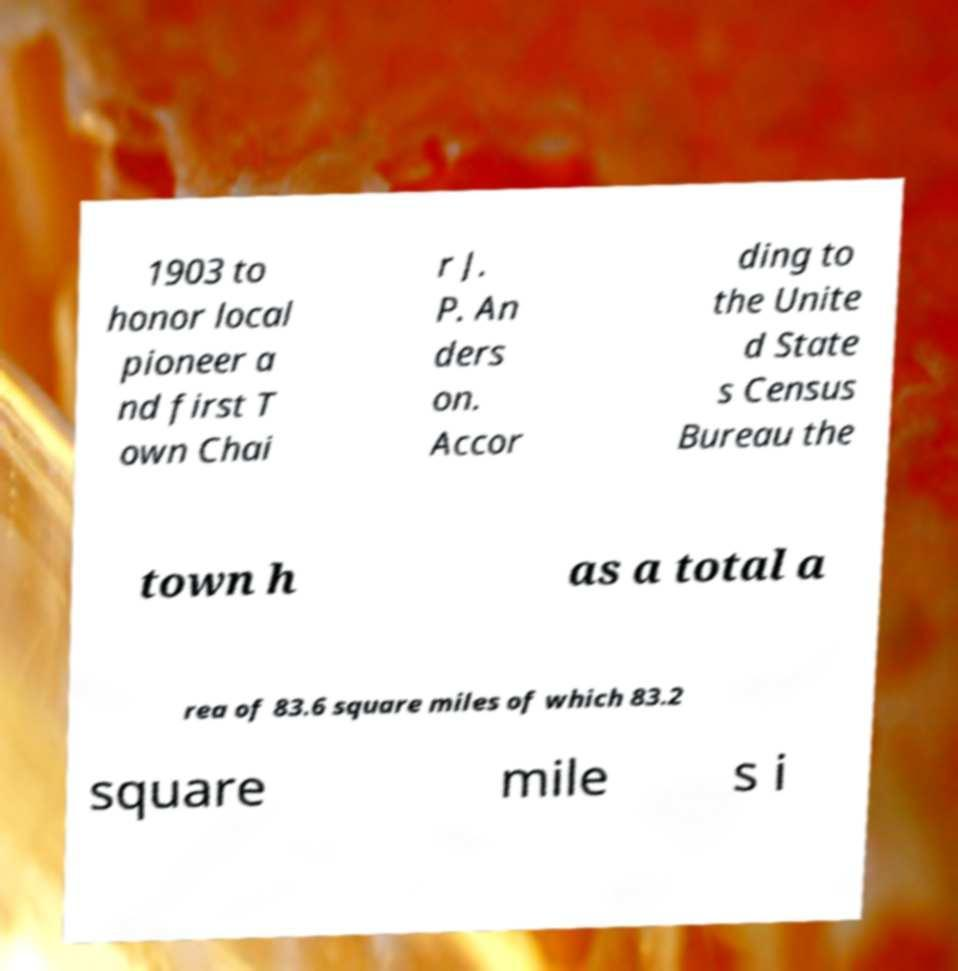I need the written content from this picture converted into text. Can you do that? 1903 to honor local pioneer a nd first T own Chai r J. P. An ders on. Accor ding to the Unite d State s Census Bureau the town h as a total a rea of 83.6 square miles of which 83.2 square mile s i 